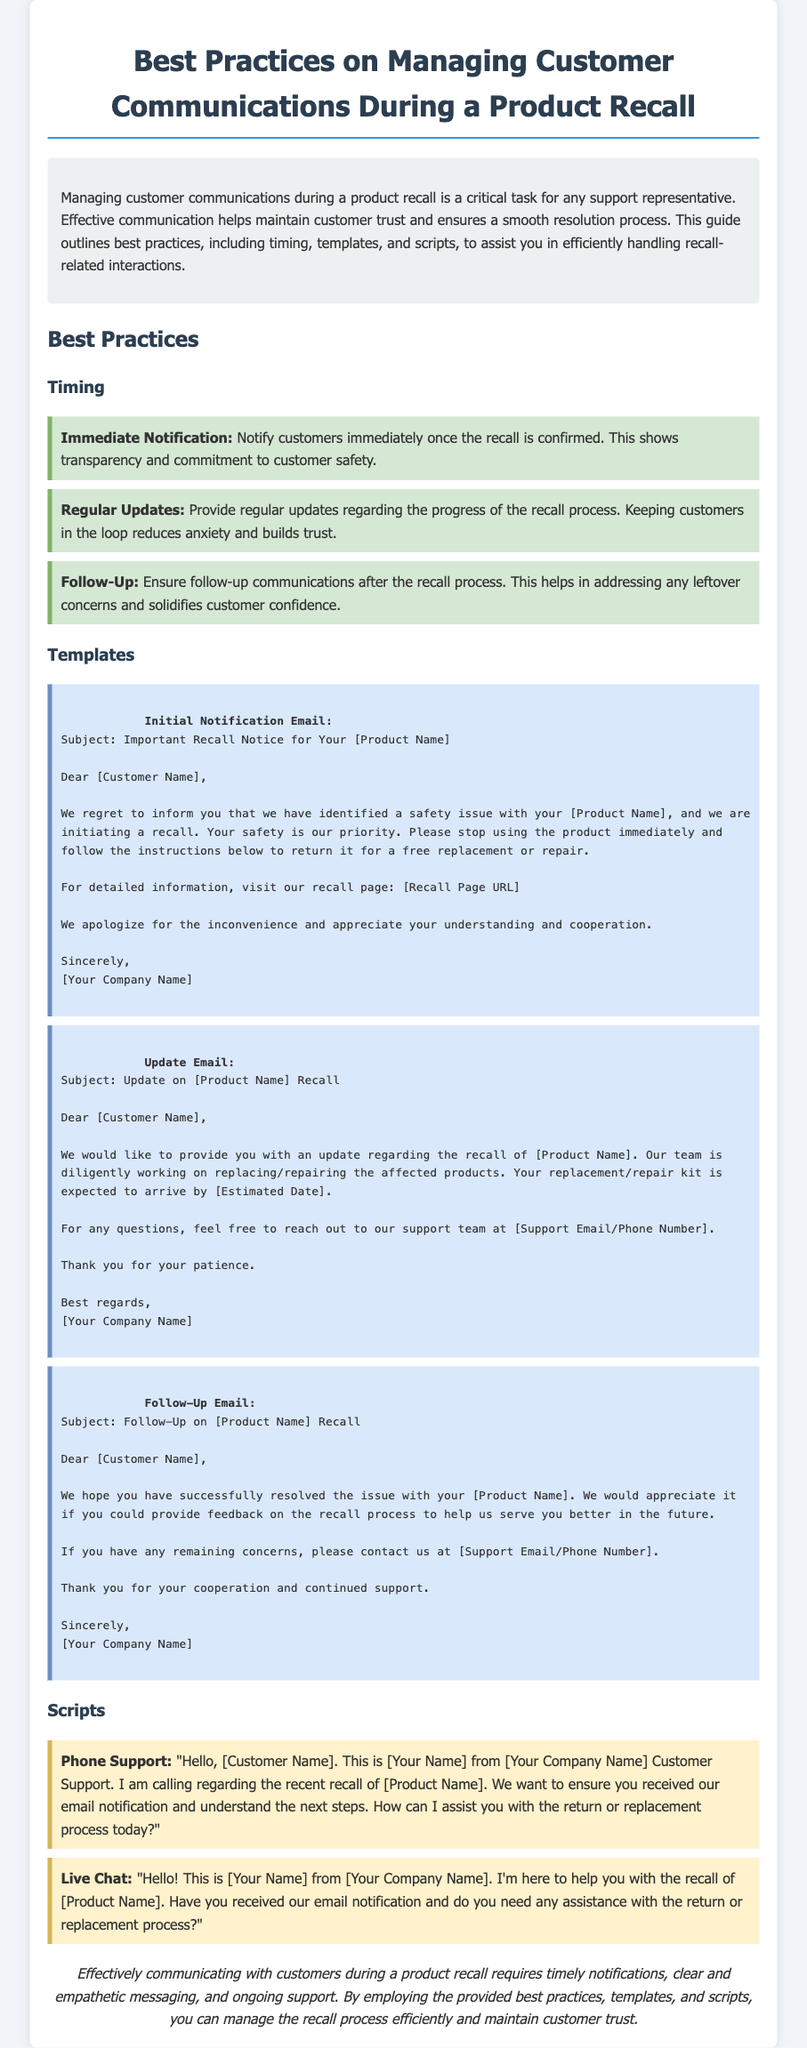what is the title of the document? The title of the document is found in the title tag of the HTML, which specifies the main focus of the content.
Answer: Best Practices on Managing Customer Communications During a Product Recall what should customers do immediately after receiving a recall notice? The document states that customers should stop using the product immediately upon receiving the recall notice.
Answer: Stop using the product immediately what is the subject of the initial notification email? The subject line for the initial notification email is necessary for clear communication and is presented in the template provided.
Answer: Important Recall Notice for Your [Product Name] how often should regular updates be provided during a recall? The document recommends providing updates regularly as part of effective communication during the recall process.
Answer: Regularly who is the sender of the emails? The emails mention the sender's identity briefly, outlining the representative's role in customer support.
Answer: [Your Company Name] what should a follow-up email request from customers? The follow-up email template indicates that feedback is requested from customers regarding the recall process.
Answer: Feedback on the recall process 